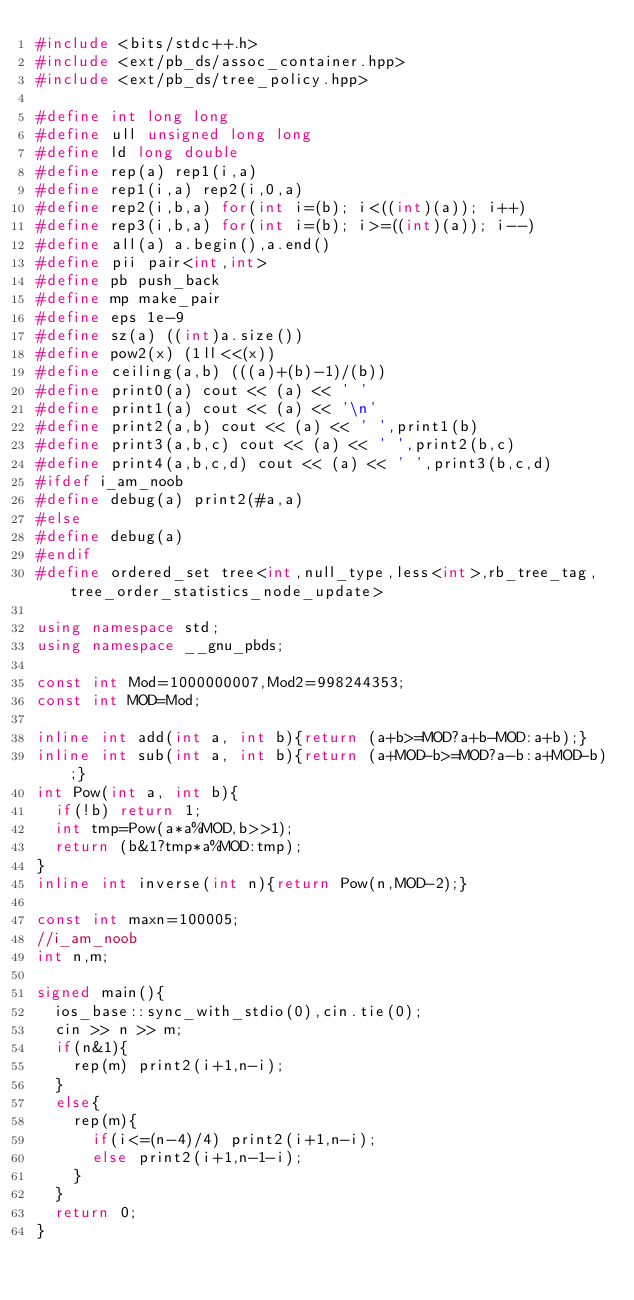Convert code to text. <code><loc_0><loc_0><loc_500><loc_500><_C++_>#include <bits/stdc++.h>
#include <ext/pb_ds/assoc_container.hpp>
#include <ext/pb_ds/tree_policy.hpp>
 
#define int long long
#define ull unsigned long long
#define ld long double
#define rep(a) rep1(i,a)
#define rep1(i,a) rep2(i,0,a)
#define rep2(i,b,a) for(int i=(b); i<((int)(a)); i++)
#define rep3(i,b,a) for(int i=(b); i>=((int)(a)); i--)
#define all(a) a.begin(),a.end()
#define pii pair<int,int>
#define pb push_back
#define mp make_pair
#define eps 1e-9
#define sz(a) ((int)a.size())
#define pow2(x) (1ll<<(x))
#define ceiling(a,b) (((a)+(b)-1)/(b))
#define print0(a) cout << (a) << ' '
#define print1(a) cout << (a) << '\n'
#define print2(a,b) cout << (a) << ' ',print1(b)
#define print3(a,b,c) cout << (a) << ' ',print2(b,c)
#define print4(a,b,c,d) cout << (a) << ' ',print3(b,c,d)
#ifdef i_am_noob
#define debug(a) print2(#a,a)
#else
#define debug(a) 
#endif
#define ordered_set tree<int,null_type,less<int>,rb_tree_tag,tree_order_statistics_node_update>
 
using namespace std;
using namespace __gnu_pbds;
 
const int Mod=1000000007,Mod2=998244353;
const int MOD=Mod;
 
inline int add(int a, int b){return (a+b>=MOD?a+b-MOD:a+b);}
inline int sub(int a, int b){return (a+MOD-b>=MOD?a-b:a+MOD-b);}
int Pow(int a, int b){
	if(!b) return 1;
	int tmp=Pow(a*a%MOD,b>>1);
	return (b&1?tmp*a%MOD:tmp);
}
inline int inverse(int n){return Pow(n,MOD-2);}
 
const int maxn=100005;
//i_am_noob
int n,m;

signed main(){
	ios_base::sync_with_stdio(0),cin.tie(0);
	cin >> n >> m;
	if(n&1){
		rep(m) print2(i+1,n-i);
	}
	else{
		rep(m){
			if(i<=(n-4)/4) print2(i+1,n-i);
			else print2(i+1,n-1-i);
		}
	}
	return 0;
}</code> 